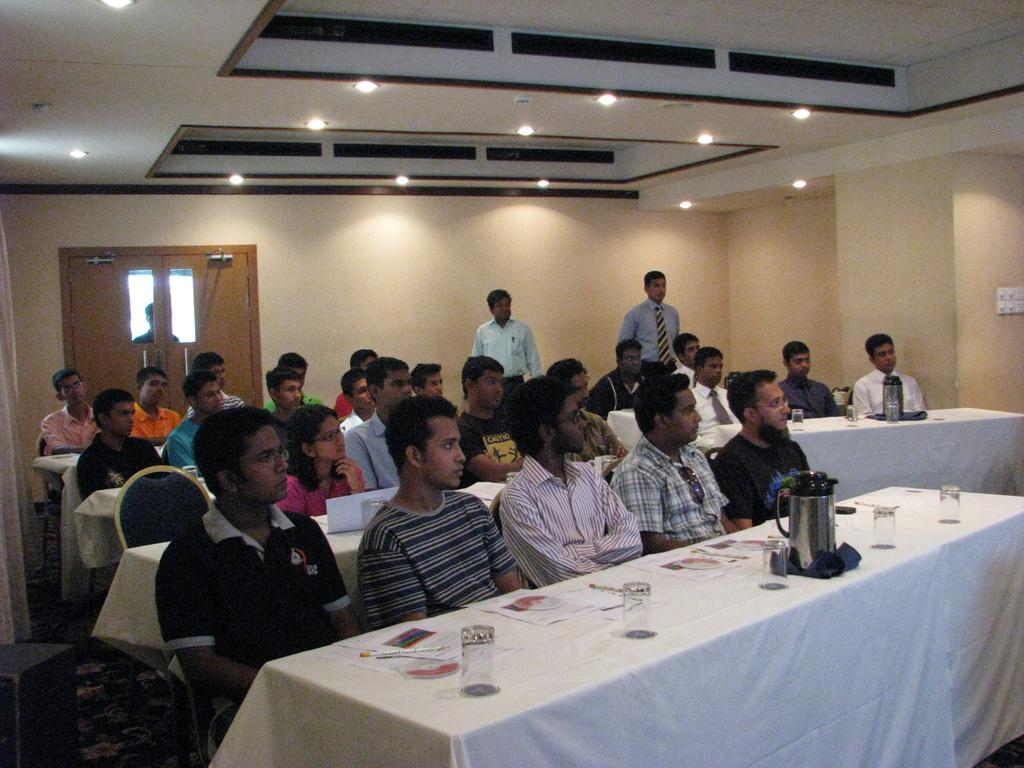What are the people in the image doing? The people in the image are seated, suggesting they might be engaged in a meeting or discussion. What are the people seated on? The people are seated on chairs. What can be seen on the table in the image? There are glasses and papers on the table. How many people are standing in the image? There are two men standing in the image. What is the connection between the week and the image? There is no direct connection between the week and the image, as the image does not provide any information about the time or day of the week. 